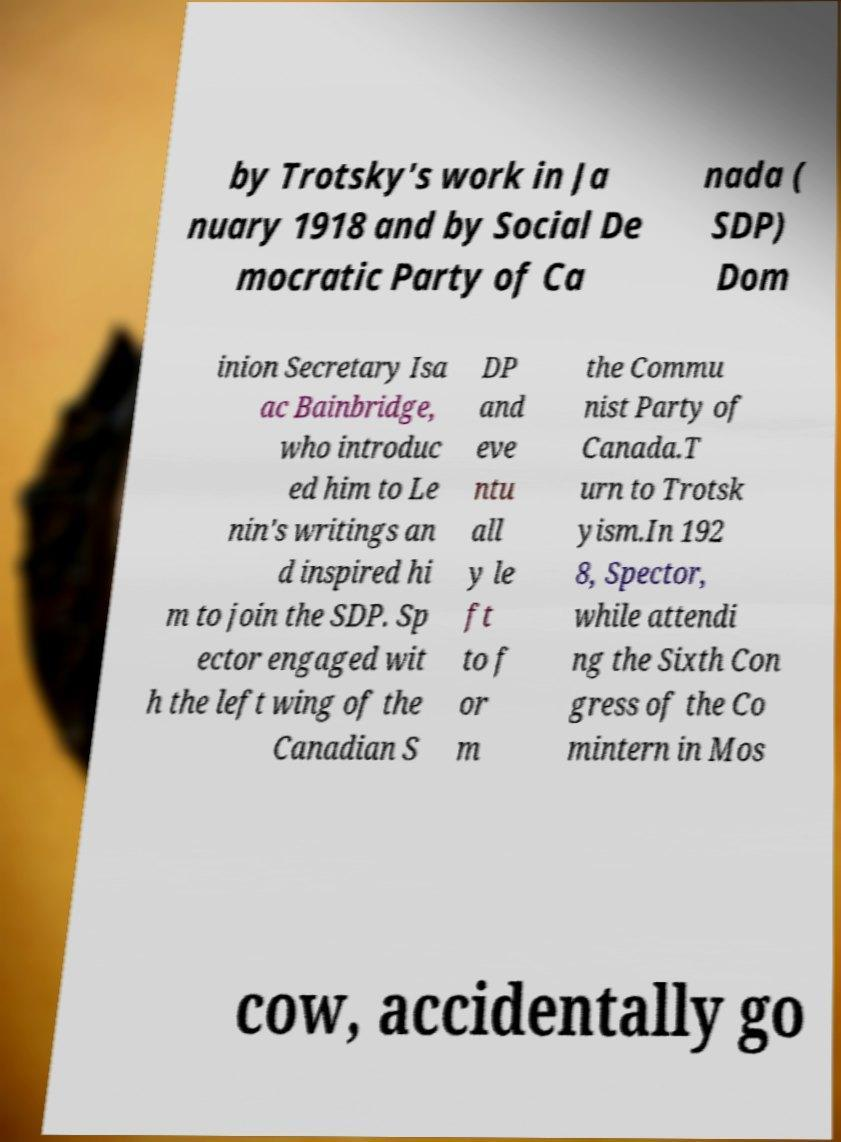Can you accurately transcribe the text from the provided image for me? by Trotsky's work in Ja nuary 1918 and by Social De mocratic Party of Ca nada ( SDP) Dom inion Secretary Isa ac Bainbridge, who introduc ed him to Le nin's writings an d inspired hi m to join the SDP. Sp ector engaged wit h the left wing of the Canadian S DP and eve ntu all y le ft to f or m the Commu nist Party of Canada.T urn to Trotsk yism.In 192 8, Spector, while attendi ng the Sixth Con gress of the Co mintern in Mos cow, accidentally go 